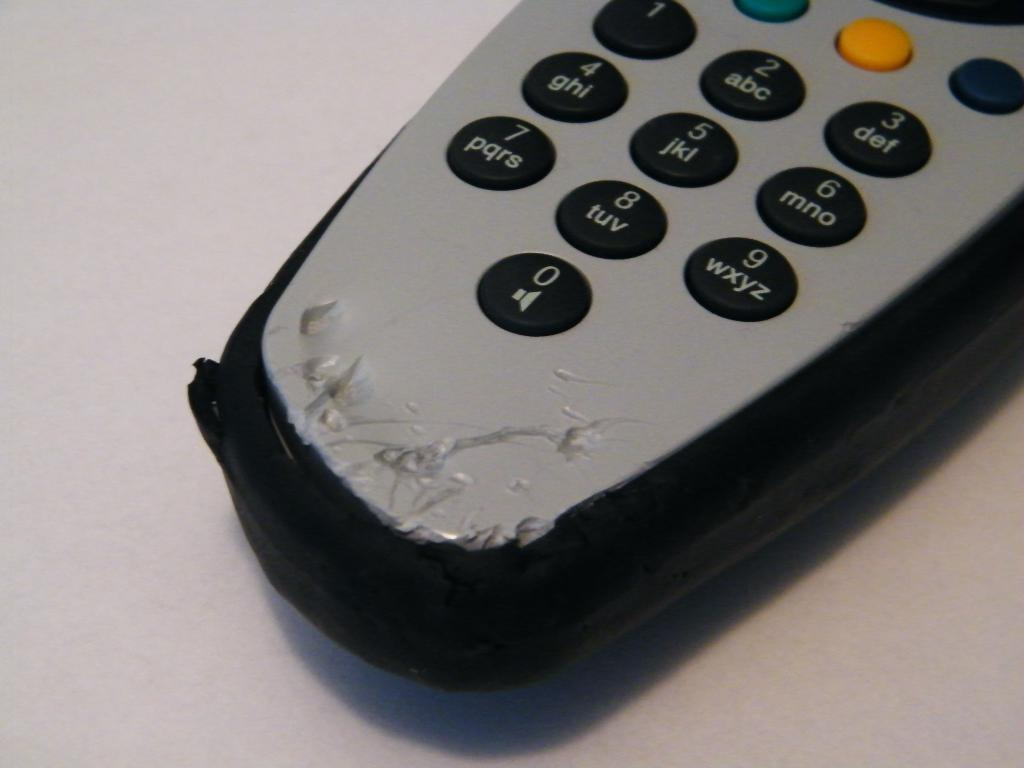Provide a one-sentence caption for the provided image. A remote control has been chewed up just below the 0. 